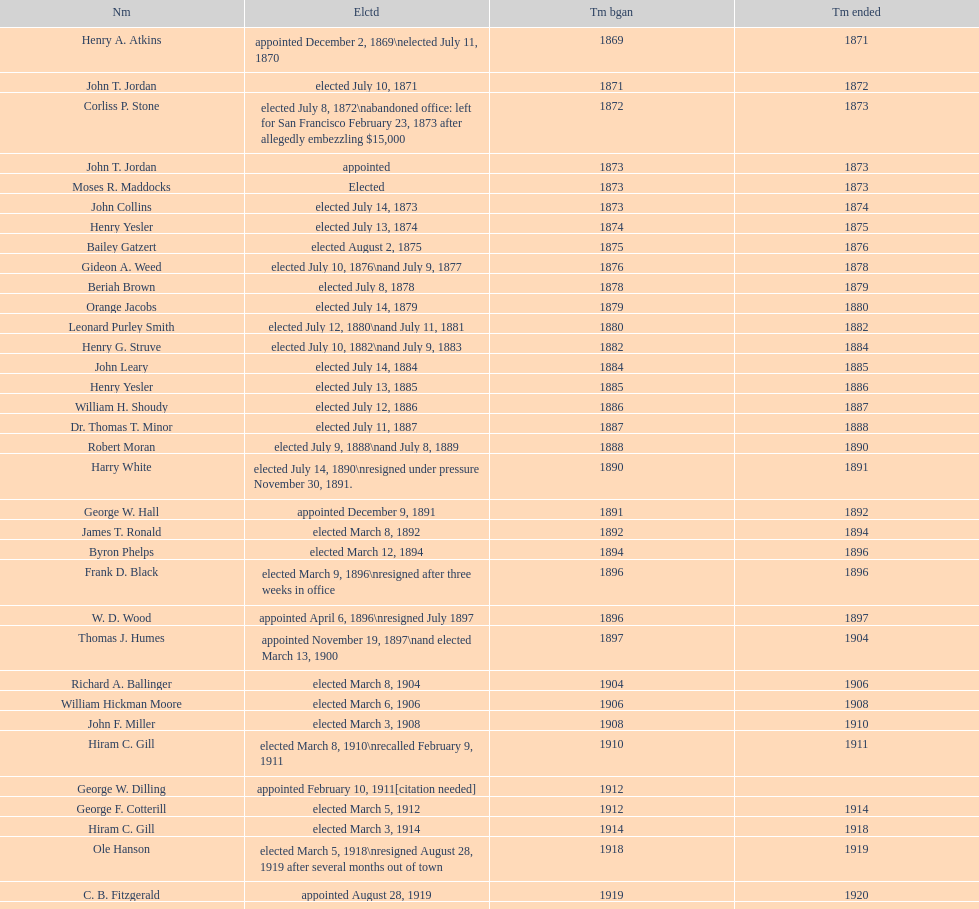Did charles royer hold office longer than paul schell? Yes. 